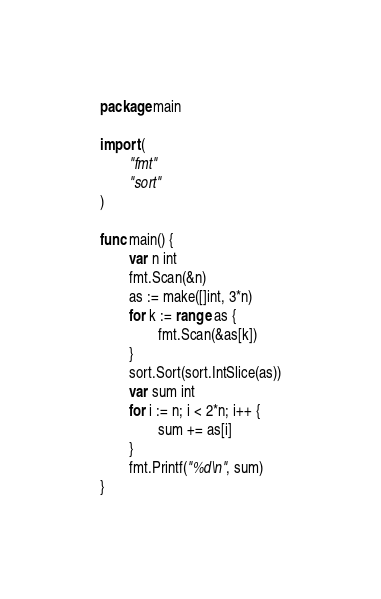<code> <loc_0><loc_0><loc_500><loc_500><_Go_>package main

import (
        "fmt"
        "sort"
)

func main() {
        var n int
        fmt.Scan(&n)
        as := make([]int, 3*n)
        for k := range as {
                fmt.Scan(&as[k])
        }
        sort.Sort(sort.IntSlice(as))
        var sum int
        for i := n; i < 2*n; i++ {
                sum += as[i]
        }
        fmt.Printf("%d\n", sum)
}</code> 